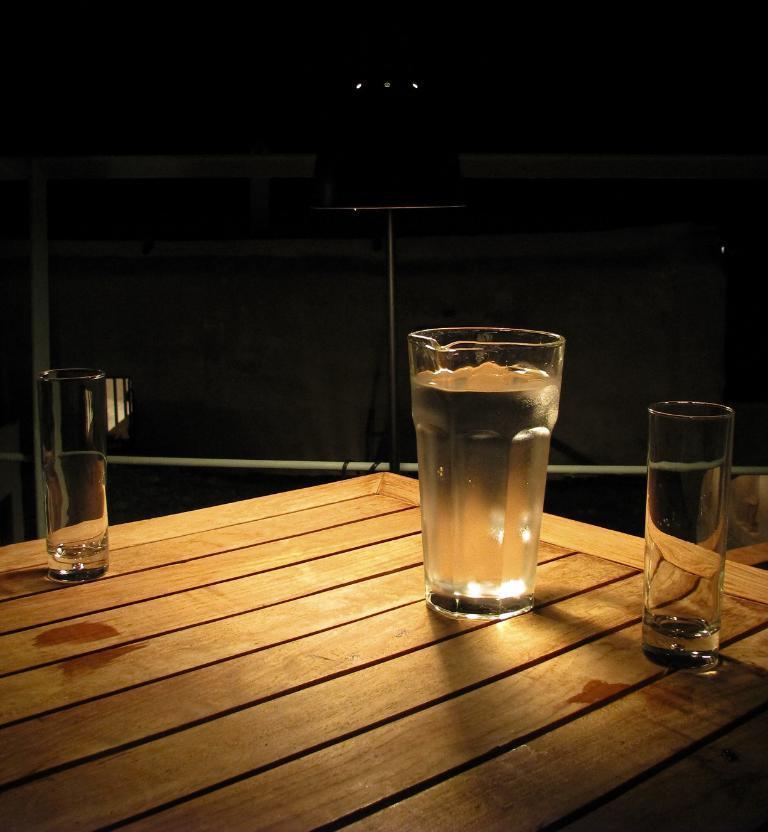How would you summarize this image in a sentence or two? This is the picture of a table on which there are three glasses. 